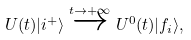<formula> <loc_0><loc_0><loc_500><loc_500>U ( t ) | i ^ { + } \rangle \stackrel { t \to + \infty } { \overrightarrow { \quad } } U ^ { 0 } ( t ) | f _ { i } \rangle ,</formula> 